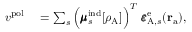<formula> <loc_0><loc_0><loc_500><loc_500>\begin{array} { r l } { { v } ^ { p o l } } & = \sum _ { s } \left ( \pm b { \mu } _ { s } ^ { i n d } [ \rho _ { A } ] \right ) ^ { T } \ \pm b { \varepsilon } _ { A , s } ^ { e } ( r _ { a } ) , } \end{array}</formula> 